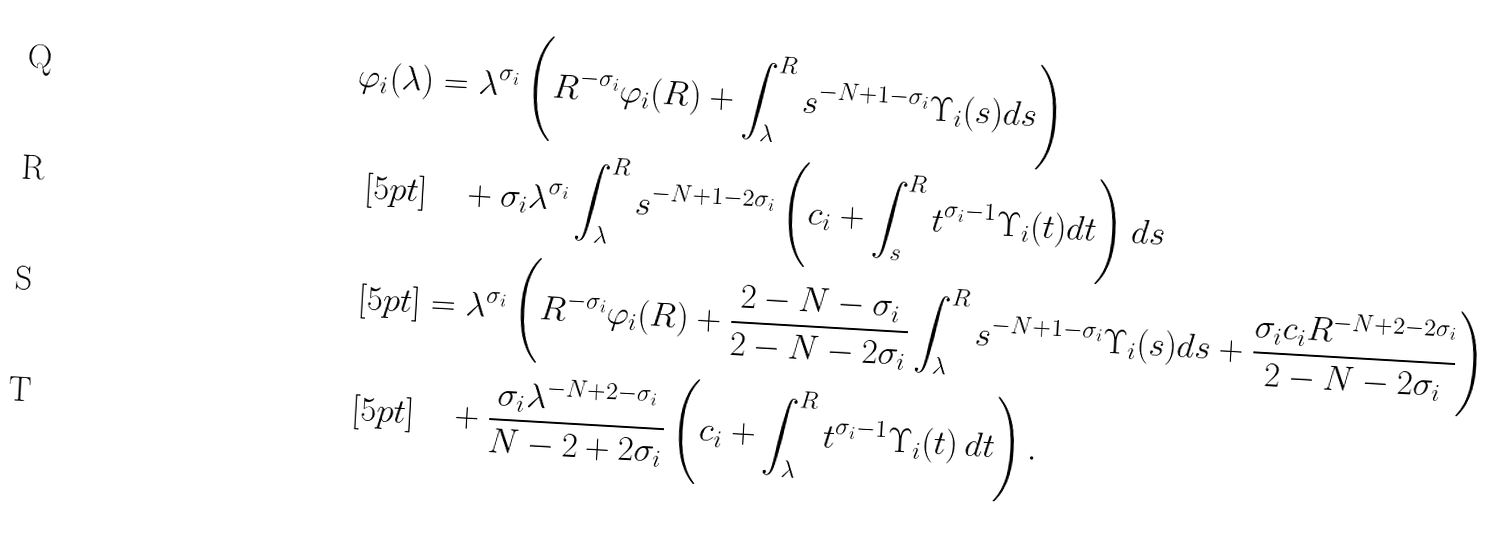<formula> <loc_0><loc_0><loc_500><loc_500>\varphi _ { i } ( \lambda ) & = \lambda ^ { \sigma _ { i } } \left ( R ^ { - \sigma _ { i } } \varphi _ { i } ( R ) + \int _ { \lambda } ^ { R } s ^ { - N + 1 - \sigma _ { i } } \Upsilon _ { i } ( s ) d s \right ) \\ [ 5 p t ] & \quad + \sigma _ { i } \lambda ^ { \sigma _ { i } } \int _ { \lambda } ^ { R } s ^ { - N + 1 - 2 \sigma _ { i } } \left ( c _ { i } + \int _ { s } ^ { R } t ^ { \sigma _ { i } - 1 } \Upsilon _ { i } ( t ) d t \right ) d s \\ [ 5 p t ] & = \lambda ^ { \sigma _ { i } } \left ( R ^ { - \sigma _ { i } } \varphi _ { i } ( R ) + \frac { 2 - N - \sigma _ { i } } { 2 - N - 2 \sigma _ { i } } \int _ { \lambda } ^ { R } s ^ { - N + 1 - \sigma _ { i } } \Upsilon _ { i } ( s ) d s + \frac { \sigma _ { i } c _ { i } R ^ { - N + 2 - 2 \sigma _ { i } } } { 2 - N - 2 \sigma _ { i } } \right ) \\ [ 5 p t ] & \quad + \frac { \sigma _ { i } \lambda ^ { - N + 2 - \sigma _ { i } } } { N - 2 + 2 \sigma _ { i } } \left ( c _ { i } + \int _ { \lambda } ^ { R } t ^ { \sigma _ { i } - 1 } \Upsilon _ { i } ( t ) \, d t \right ) .</formula> 